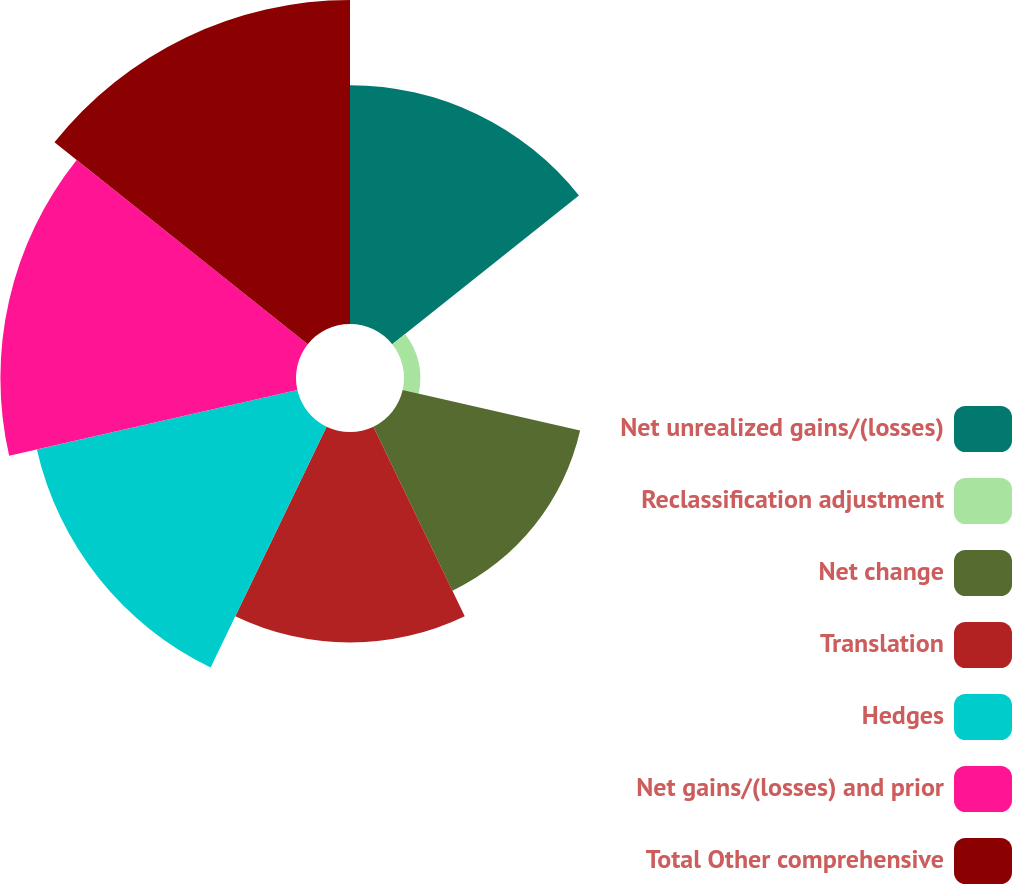Convert chart. <chart><loc_0><loc_0><loc_500><loc_500><pie_chart><fcel>Net unrealized gains/(losses)<fcel>Reclassification adjustment<fcel>Net change<fcel>Translation<fcel>Hedges<fcel>Net gains/(losses) and prior<fcel>Total Other comprehensive<nl><fcel>15.56%<fcel>1.07%<fcel>11.86%<fcel>13.71%<fcel>17.41%<fcel>19.26%<fcel>21.11%<nl></chart> 